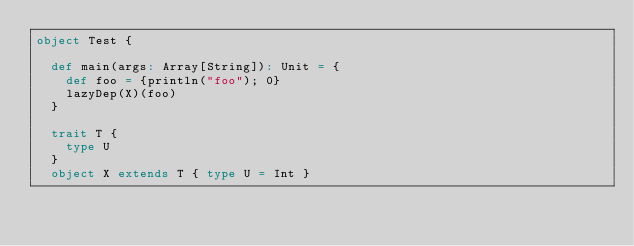<code> <loc_0><loc_0><loc_500><loc_500><_Scala_>object Test {

  def main(args: Array[String]): Unit = {
    def foo = {println("foo"); 0}
    lazyDep(X)(foo)
  }

  trait T {
    type U
  }
  object X extends T { type U = Int }
</code> 